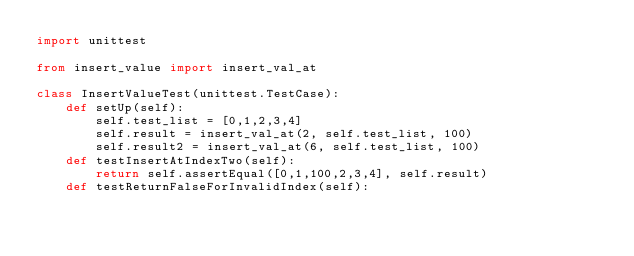<code> <loc_0><loc_0><loc_500><loc_500><_Python_>import unittest

from insert_value import insert_val_at

class InsertValueTest(unittest.TestCase):
    def setUp(self):
        self.test_list = [0,1,2,3,4]
        self.result = insert_val_at(2, self.test_list, 100)
        self.result2 = insert_val_at(6, self.test_list, 100)
    def testInsertAtIndexTwo(self):
        return self.assertEqual([0,1,100,2,3,4], self.result)
    def testReturnFalseForInvalidIndex(self):</code> 